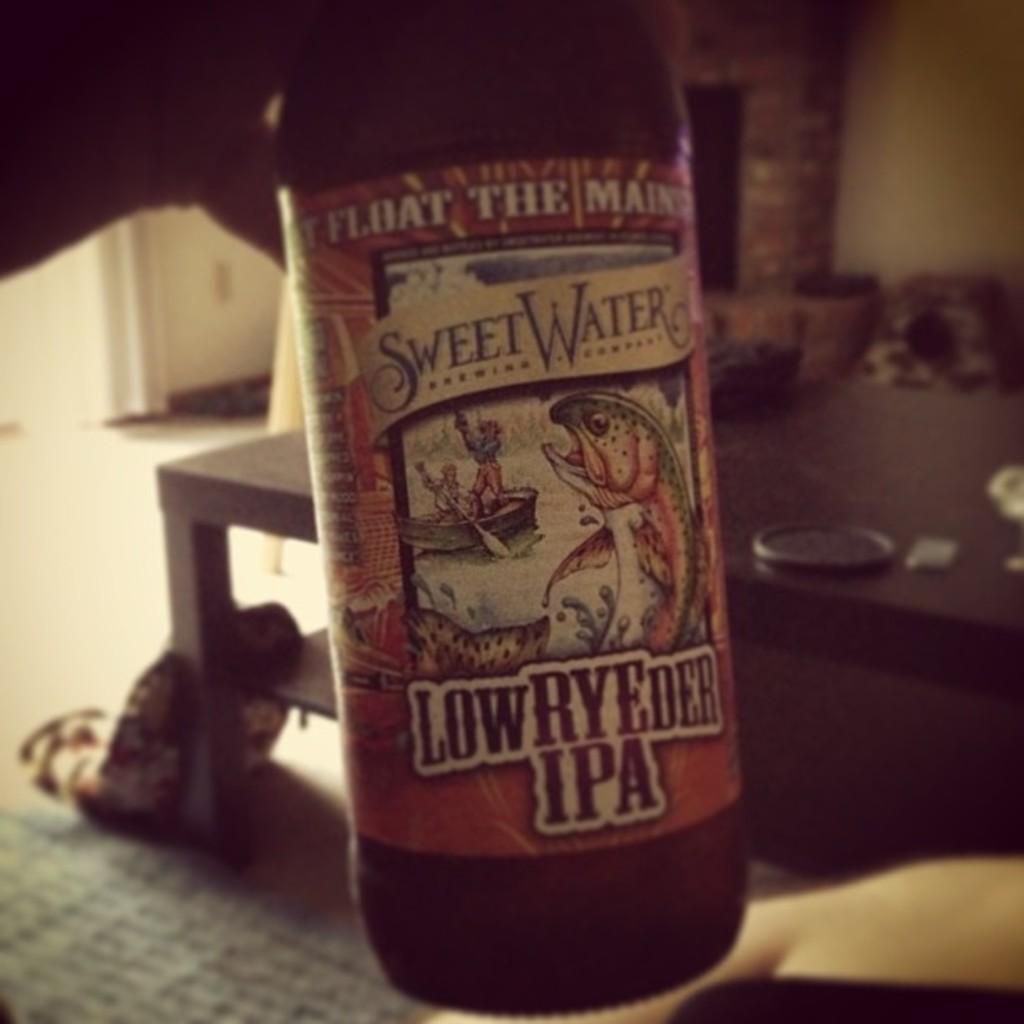<image>
Offer a succinct explanation of the picture presented. The name of the bottle advertised is sweet water. 